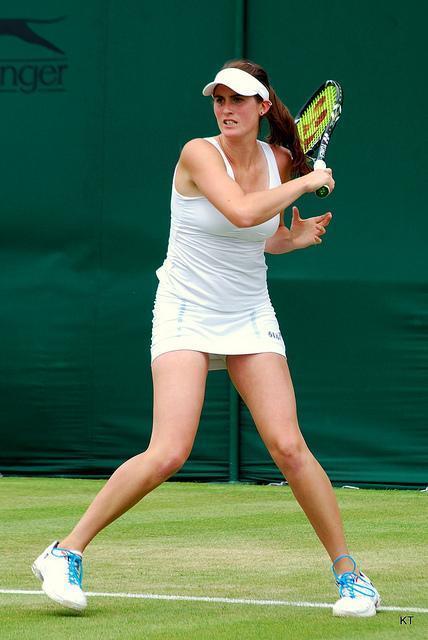How many dogs are in the photo?
Give a very brief answer. 0. 